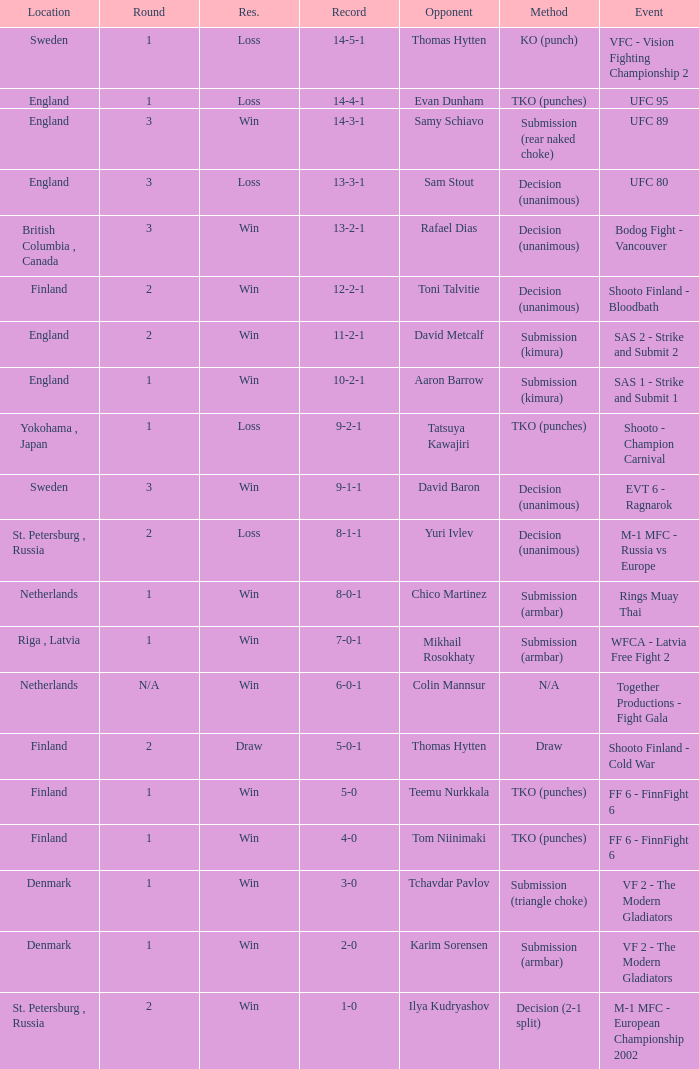What is the round in Finland with a draw for method? 2.0. 